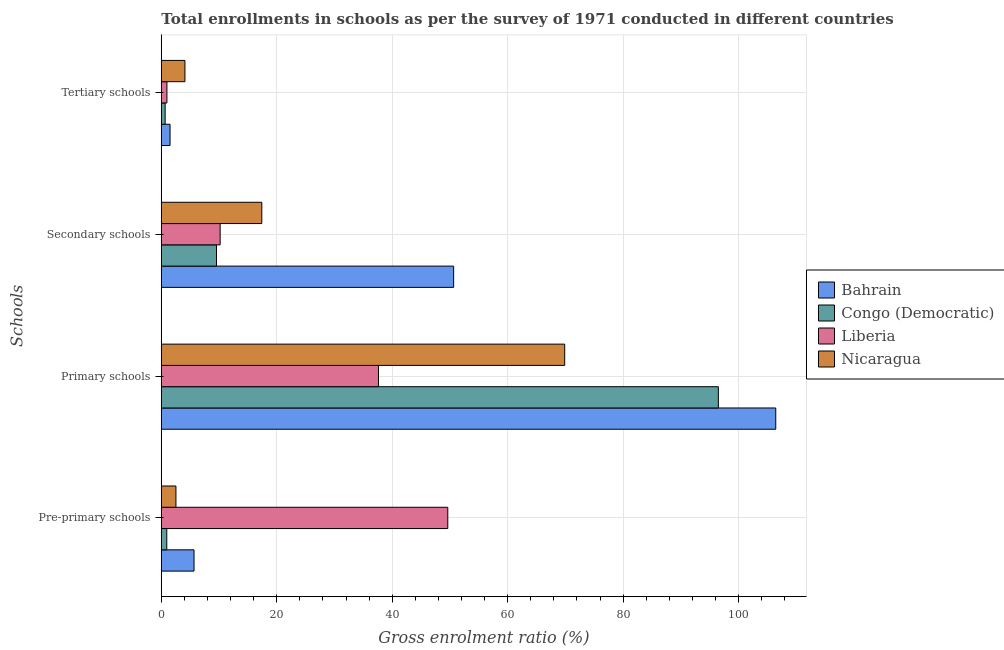Are the number of bars per tick equal to the number of legend labels?
Keep it short and to the point. Yes. What is the label of the 1st group of bars from the top?
Your answer should be compact. Tertiary schools. What is the gross enrolment ratio in pre-primary schools in Congo (Democratic)?
Provide a short and direct response. 0.95. Across all countries, what is the maximum gross enrolment ratio in secondary schools?
Offer a terse response. 50.63. Across all countries, what is the minimum gross enrolment ratio in pre-primary schools?
Offer a very short reply. 0.95. In which country was the gross enrolment ratio in pre-primary schools maximum?
Your response must be concise. Liberia. In which country was the gross enrolment ratio in tertiary schools minimum?
Offer a very short reply. Congo (Democratic). What is the total gross enrolment ratio in primary schools in the graph?
Provide a short and direct response. 310.41. What is the difference between the gross enrolment ratio in tertiary schools in Congo (Democratic) and that in Bahrain?
Offer a terse response. -0.85. What is the difference between the gross enrolment ratio in secondary schools in Liberia and the gross enrolment ratio in tertiary schools in Bahrain?
Provide a short and direct response. 8.68. What is the average gross enrolment ratio in tertiary schools per country?
Offer a terse response. 1.81. What is the difference between the gross enrolment ratio in secondary schools and gross enrolment ratio in primary schools in Liberia?
Give a very brief answer. -27.42. What is the ratio of the gross enrolment ratio in secondary schools in Nicaragua to that in Liberia?
Provide a succinct answer. 1.71. Is the gross enrolment ratio in primary schools in Bahrain less than that in Nicaragua?
Provide a succinct answer. No. Is the difference between the gross enrolment ratio in tertiary schools in Congo (Democratic) and Liberia greater than the difference between the gross enrolment ratio in primary schools in Congo (Democratic) and Liberia?
Offer a terse response. No. What is the difference between the highest and the second highest gross enrolment ratio in secondary schools?
Offer a terse response. 33.23. What is the difference between the highest and the lowest gross enrolment ratio in tertiary schools?
Give a very brief answer. 3.43. Is it the case that in every country, the sum of the gross enrolment ratio in tertiary schools and gross enrolment ratio in pre-primary schools is greater than the sum of gross enrolment ratio in primary schools and gross enrolment ratio in secondary schools?
Your answer should be compact. No. What does the 1st bar from the top in Tertiary schools represents?
Provide a succinct answer. Nicaragua. What does the 2nd bar from the bottom in Tertiary schools represents?
Offer a terse response. Congo (Democratic). How many bars are there?
Make the answer very short. 16. How many countries are there in the graph?
Your response must be concise. 4. What is the difference between two consecutive major ticks on the X-axis?
Make the answer very short. 20. Does the graph contain any zero values?
Give a very brief answer. No. Does the graph contain grids?
Make the answer very short. Yes. What is the title of the graph?
Your answer should be very brief. Total enrollments in schools as per the survey of 1971 conducted in different countries. Does "Norway" appear as one of the legend labels in the graph?
Offer a terse response. No. What is the label or title of the X-axis?
Provide a short and direct response. Gross enrolment ratio (%). What is the label or title of the Y-axis?
Keep it short and to the point. Schools. What is the Gross enrolment ratio (%) in Bahrain in Pre-primary schools?
Give a very brief answer. 5.67. What is the Gross enrolment ratio (%) of Congo (Democratic) in Pre-primary schools?
Offer a very short reply. 0.95. What is the Gross enrolment ratio (%) of Liberia in Pre-primary schools?
Your response must be concise. 49.62. What is the Gross enrolment ratio (%) of Nicaragua in Pre-primary schools?
Keep it short and to the point. 2.53. What is the Gross enrolment ratio (%) of Bahrain in Primary schools?
Keep it short and to the point. 106.43. What is the Gross enrolment ratio (%) of Congo (Democratic) in Primary schools?
Ensure brevity in your answer.  96.49. What is the Gross enrolment ratio (%) of Liberia in Primary schools?
Your response must be concise. 37.62. What is the Gross enrolment ratio (%) of Nicaragua in Primary schools?
Your answer should be compact. 69.87. What is the Gross enrolment ratio (%) of Bahrain in Secondary schools?
Offer a very short reply. 50.63. What is the Gross enrolment ratio (%) of Congo (Democratic) in Secondary schools?
Your answer should be very brief. 9.56. What is the Gross enrolment ratio (%) in Liberia in Secondary schools?
Offer a terse response. 10.19. What is the Gross enrolment ratio (%) of Nicaragua in Secondary schools?
Your answer should be compact. 17.41. What is the Gross enrolment ratio (%) in Bahrain in Tertiary schools?
Keep it short and to the point. 1.51. What is the Gross enrolment ratio (%) of Congo (Democratic) in Tertiary schools?
Offer a very short reply. 0.66. What is the Gross enrolment ratio (%) of Liberia in Tertiary schools?
Keep it short and to the point. 0.97. What is the Gross enrolment ratio (%) in Nicaragua in Tertiary schools?
Ensure brevity in your answer.  4.09. Across all Schools, what is the maximum Gross enrolment ratio (%) of Bahrain?
Your answer should be very brief. 106.43. Across all Schools, what is the maximum Gross enrolment ratio (%) in Congo (Democratic)?
Your answer should be very brief. 96.49. Across all Schools, what is the maximum Gross enrolment ratio (%) in Liberia?
Provide a short and direct response. 49.62. Across all Schools, what is the maximum Gross enrolment ratio (%) of Nicaragua?
Ensure brevity in your answer.  69.87. Across all Schools, what is the minimum Gross enrolment ratio (%) in Bahrain?
Offer a very short reply. 1.51. Across all Schools, what is the minimum Gross enrolment ratio (%) of Congo (Democratic)?
Provide a short and direct response. 0.66. Across all Schools, what is the minimum Gross enrolment ratio (%) of Liberia?
Offer a very short reply. 0.97. Across all Schools, what is the minimum Gross enrolment ratio (%) of Nicaragua?
Keep it short and to the point. 2.53. What is the total Gross enrolment ratio (%) in Bahrain in the graph?
Offer a very short reply. 164.24. What is the total Gross enrolment ratio (%) of Congo (Democratic) in the graph?
Make the answer very short. 107.66. What is the total Gross enrolment ratio (%) of Liberia in the graph?
Offer a terse response. 98.4. What is the total Gross enrolment ratio (%) in Nicaragua in the graph?
Offer a terse response. 93.9. What is the difference between the Gross enrolment ratio (%) in Bahrain in Pre-primary schools and that in Primary schools?
Ensure brevity in your answer.  -100.77. What is the difference between the Gross enrolment ratio (%) of Congo (Democratic) in Pre-primary schools and that in Primary schools?
Your answer should be very brief. -95.55. What is the difference between the Gross enrolment ratio (%) of Liberia in Pre-primary schools and that in Primary schools?
Ensure brevity in your answer.  12. What is the difference between the Gross enrolment ratio (%) in Nicaragua in Pre-primary schools and that in Primary schools?
Provide a succinct answer. -67.34. What is the difference between the Gross enrolment ratio (%) in Bahrain in Pre-primary schools and that in Secondary schools?
Make the answer very short. -44.97. What is the difference between the Gross enrolment ratio (%) in Congo (Democratic) in Pre-primary schools and that in Secondary schools?
Offer a very short reply. -8.61. What is the difference between the Gross enrolment ratio (%) of Liberia in Pre-primary schools and that in Secondary schools?
Offer a very short reply. 39.43. What is the difference between the Gross enrolment ratio (%) in Nicaragua in Pre-primary schools and that in Secondary schools?
Give a very brief answer. -14.88. What is the difference between the Gross enrolment ratio (%) of Bahrain in Pre-primary schools and that in Tertiary schools?
Provide a succinct answer. 4.15. What is the difference between the Gross enrolment ratio (%) of Congo (Democratic) in Pre-primary schools and that in Tertiary schools?
Provide a succinct answer. 0.28. What is the difference between the Gross enrolment ratio (%) of Liberia in Pre-primary schools and that in Tertiary schools?
Your answer should be very brief. 48.65. What is the difference between the Gross enrolment ratio (%) of Nicaragua in Pre-primary schools and that in Tertiary schools?
Make the answer very short. -1.56. What is the difference between the Gross enrolment ratio (%) of Bahrain in Primary schools and that in Secondary schools?
Provide a short and direct response. 55.8. What is the difference between the Gross enrolment ratio (%) of Congo (Democratic) in Primary schools and that in Secondary schools?
Provide a succinct answer. 86.94. What is the difference between the Gross enrolment ratio (%) of Liberia in Primary schools and that in Secondary schools?
Give a very brief answer. 27.42. What is the difference between the Gross enrolment ratio (%) in Nicaragua in Primary schools and that in Secondary schools?
Your answer should be very brief. 52.46. What is the difference between the Gross enrolment ratio (%) in Bahrain in Primary schools and that in Tertiary schools?
Provide a short and direct response. 104.92. What is the difference between the Gross enrolment ratio (%) in Congo (Democratic) in Primary schools and that in Tertiary schools?
Make the answer very short. 95.83. What is the difference between the Gross enrolment ratio (%) of Liberia in Primary schools and that in Tertiary schools?
Your answer should be compact. 36.65. What is the difference between the Gross enrolment ratio (%) in Nicaragua in Primary schools and that in Tertiary schools?
Your response must be concise. 65.78. What is the difference between the Gross enrolment ratio (%) of Bahrain in Secondary schools and that in Tertiary schools?
Your answer should be very brief. 49.12. What is the difference between the Gross enrolment ratio (%) of Congo (Democratic) in Secondary schools and that in Tertiary schools?
Your answer should be very brief. 8.89. What is the difference between the Gross enrolment ratio (%) in Liberia in Secondary schools and that in Tertiary schools?
Your answer should be very brief. 9.22. What is the difference between the Gross enrolment ratio (%) of Nicaragua in Secondary schools and that in Tertiary schools?
Provide a succinct answer. 13.32. What is the difference between the Gross enrolment ratio (%) in Bahrain in Pre-primary schools and the Gross enrolment ratio (%) in Congo (Democratic) in Primary schools?
Your answer should be very brief. -90.82. What is the difference between the Gross enrolment ratio (%) of Bahrain in Pre-primary schools and the Gross enrolment ratio (%) of Liberia in Primary schools?
Keep it short and to the point. -31.95. What is the difference between the Gross enrolment ratio (%) in Bahrain in Pre-primary schools and the Gross enrolment ratio (%) in Nicaragua in Primary schools?
Offer a terse response. -64.21. What is the difference between the Gross enrolment ratio (%) of Congo (Democratic) in Pre-primary schools and the Gross enrolment ratio (%) of Liberia in Primary schools?
Your answer should be compact. -36.67. What is the difference between the Gross enrolment ratio (%) in Congo (Democratic) in Pre-primary schools and the Gross enrolment ratio (%) in Nicaragua in Primary schools?
Make the answer very short. -68.93. What is the difference between the Gross enrolment ratio (%) in Liberia in Pre-primary schools and the Gross enrolment ratio (%) in Nicaragua in Primary schools?
Make the answer very short. -20.25. What is the difference between the Gross enrolment ratio (%) of Bahrain in Pre-primary schools and the Gross enrolment ratio (%) of Congo (Democratic) in Secondary schools?
Provide a succinct answer. -3.89. What is the difference between the Gross enrolment ratio (%) in Bahrain in Pre-primary schools and the Gross enrolment ratio (%) in Liberia in Secondary schools?
Keep it short and to the point. -4.53. What is the difference between the Gross enrolment ratio (%) of Bahrain in Pre-primary schools and the Gross enrolment ratio (%) of Nicaragua in Secondary schools?
Ensure brevity in your answer.  -11.74. What is the difference between the Gross enrolment ratio (%) in Congo (Democratic) in Pre-primary schools and the Gross enrolment ratio (%) in Liberia in Secondary schools?
Offer a terse response. -9.25. What is the difference between the Gross enrolment ratio (%) of Congo (Democratic) in Pre-primary schools and the Gross enrolment ratio (%) of Nicaragua in Secondary schools?
Keep it short and to the point. -16.46. What is the difference between the Gross enrolment ratio (%) in Liberia in Pre-primary schools and the Gross enrolment ratio (%) in Nicaragua in Secondary schools?
Provide a short and direct response. 32.21. What is the difference between the Gross enrolment ratio (%) of Bahrain in Pre-primary schools and the Gross enrolment ratio (%) of Congo (Democratic) in Tertiary schools?
Provide a succinct answer. 5. What is the difference between the Gross enrolment ratio (%) in Bahrain in Pre-primary schools and the Gross enrolment ratio (%) in Liberia in Tertiary schools?
Make the answer very short. 4.7. What is the difference between the Gross enrolment ratio (%) in Bahrain in Pre-primary schools and the Gross enrolment ratio (%) in Nicaragua in Tertiary schools?
Your answer should be compact. 1.57. What is the difference between the Gross enrolment ratio (%) of Congo (Democratic) in Pre-primary schools and the Gross enrolment ratio (%) of Liberia in Tertiary schools?
Give a very brief answer. -0.02. What is the difference between the Gross enrolment ratio (%) of Congo (Democratic) in Pre-primary schools and the Gross enrolment ratio (%) of Nicaragua in Tertiary schools?
Ensure brevity in your answer.  -3.15. What is the difference between the Gross enrolment ratio (%) in Liberia in Pre-primary schools and the Gross enrolment ratio (%) in Nicaragua in Tertiary schools?
Offer a very short reply. 45.53. What is the difference between the Gross enrolment ratio (%) in Bahrain in Primary schools and the Gross enrolment ratio (%) in Congo (Democratic) in Secondary schools?
Offer a terse response. 96.88. What is the difference between the Gross enrolment ratio (%) in Bahrain in Primary schools and the Gross enrolment ratio (%) in Liberia in Secondary schools?
Your answer should be very brief. 96.24. What is the difference between the Gross enrolment ratio (%) of Bahrain in Primary schools and the Gross enrolment ratio (%) of Nicaragua in Secondary schools?
Your answer should be very brief. 89.02. What is the difference between the Gross enrolment ratio (%) of Congo (Democratic) in Primary schools and the Gross enrolment ratio (%) of Liberia in Secondary schools?
Your response must be concise. 86.3. What is the difference between the Gross enrolment ratio (%) of Congo (Democratic) in Primary schools and the Gross enrolment ratio (%) of Nicaragua in Secondary schools?
Your answer should be very brief. 79.08. What is the difference between the Gross enrolment ratio (%) of Liberia in Primary schools and the Gross enrolment ratio (%) of Nicaragua in Secondary schools?
Ensure brevity in your answer.  20.21. What is the difference between the Gross enrolment ratio (%) in Bahrain in Primary schools and the Gross enrolment ratio (%) in Congo (Democratic) in Tertiary schools?
Offer a very short reply. 105.77. What is the difference between the Gross enrolment ratio (%) in Bahrain in Primary schools and the Gross enrolment ratio (%) in Liberia in Tertiary schools?
Give a very brief answer. 105.46. What is the difference between the Gross enrolment ratio (%) of Bahrain in Primary schools and the Gross enrolment ratio (%) of Nicaragua in Tertiary schools?
Provide a succinct answer. 102.34. What is the difference between the Gross enrolment ratio (%) of Congo (Democratic) in Primary schools and the Gross enrolment ratio (%) of Liberia in Tertiary schools?
Ensure brevity in your answer.  95.52. What is the difference between the Gross enrolment ratio (%) in Congo (Democratic) in Primary schools and the Gross enrolment ratio (%) in Nicaragua in Tertiary schools?
Provide a succinct answer. 92.4. What is the difference between the Gross enrolment ratio (%) in Liberia in Primary schools and the Gross enrolment ratio (%) in Nicaragua in Tertiary schools?
Ensure brevity in your answer.  33.53. What is the difference between the Gross enrolment ratio (%) in Bahrain in Secondary schools and the Gross enrolment ratio (%) in Congo (Democratic) in Tertiary schools?
Keep it short and to the point. 49.97. What is the difference between the Gross enrolment ratio (%) in Bahrain in Secondary schools and the Gross enrolment ratio (%) in Liberia in Tertiary schools?
Your answer should be compact. 49.66. What is the difference between the Gross enrolment ratio (%) in Bahrain in Secondary schools and the Gross enrolment ratio (%) in Nicaragua in Tertiary schools?
Your answer should be very brief. 46.54. What is the difference between the Gross enrolment ratio (%) of Congo (Democratic) in Secondary schools and the Gross enrolment ratio (%) of Liberia in Tertiary schools?
Provide a succinct answer. 8.59. What is the difference between the Gross enrolment ratio (%) of Congo (Democratic) in Secondary schools and the Gross enrolment ratio (%) of Nicaragua in Tertiary schools?
Your answer should be very brief. 5.46. What is the difference between the Gross enrolment ratio (%) in Liberia in Secondary schools and the Gross enrolment ratio (%) in Nicaragua in Tertiary schools?
Make the answer very short. 6.1. What is the average Gross enrolment ratio (%) of Bahrain per Schools?
Keep it short and to the point. 41.06. What is the average Gross enrolment ratio (%) in Congo (Democratic) per Schools?
Offer a terse response. 26.91. What is the average Gross enrolment ratio (%) of Liberia per Schools?
Your answer should be very brief. 24.6. What is the average Gross enrolment ratio (%) of Nicaragua per Schools?
Keep it short and to the point. 23.48. What is the difference between the Gross enrolment ratio (%) of Bahrain and Gross enrolment ratio (%) of Congo (Democratic) in Pre-primary schools?
Keep it short and to the point. 4.72. What is the difference between the Gross enrolment ratio (%) of Bahrain and Gross enrolment ratio (%) of Liberia in Pre-primary schools?
Provide a short and direct response. -43.95. What is the difference between the Gross enrolment ratio (%) of Bahrain and Gross enrolment ratio (%) of Nicaragua in Pre-primary schools?
Offer a very short reply. 3.13. What is the difference between the Gross enrolment ratio (%) in Congo (Democratic) and Gross enrolment ratio (%) in Liberia in Pre-primary schools?
Give a very brief answer. -48.67. What is the difference between the Gross enrolment ratio (%) in Congo (Democratic) and Gross enrolment ratio (%) in Nicaragua in Pre-primary schools?
Provide a succinct answer. -1.59. What is the difference between the Gross enrolment ratio (%) in Liberia and Gross enrolment ratio (%) in Nicaragua in Pre-primary schools?
Your response must be concise. 47.09. What is the difference between the Gross enrolment ratio (%) in Bahrain and Gross enrolment ratio (%) in Congo (Democratic) in Primary schools?
Give a very brief answer. 9.94. What is the difference between the Gross enrolment ratio (%) in Bahrain and Gross enrolment ratio (%) in Liberia in Primary schools?
Provide a short and direct response. 68.81. What is the difference between the Gross enrolment ratio (%) in Bahrain and Gross enrolment ratio (%) in Nicaragua in Primary schools?
Offer a terse response. 36.56. What is the difference between the Gross enrolment ratio (%) in Congo (Democratic) and Gross enrolment ratio (%) in Liberia in Primary schools?
Offer a terse response. 58.87. What is the difference between the Gross enrolment ratio (%) in Congo (Democratic) and Gross enrolment ratio (%) in Nicaragua in Primary schools?
Provide a succinct answer. 26.62. What is the difference between the Gross enrolment ratio (%) of Liberia and Gross enrolment ratio (%) of Nicaragua in Primary schools?
Ensure brevity in your answer.  -32.25. What is the difference between the Gross enrolment ratio (%) of Bahrain and Gross enrolment ratio (%) of Congo (Democratic) in Secondary schools?
Provide a succinct answer. 41.08. What is the difference between the Gross enrolment ratio (%) in Bahrain and Gross enrolment ratio (%) in Liberia in Secondary schools?
Your answer should be compact. 40.44. What is the difference between the Gross enrolment ratio (%) of Bahrain and Gross enrolment ratio (%) of Nicaragua in Secondary schools?
Make the answer very short. 33.23. What is the difference between the Gross enrolment ratio (%) of Congo (Democratic) and Gross enrolment ratio (%) of Liberia in Secondary schools?
Provide a succinct answer. -0.64. What is the difference between the Gross enrolment ratio (%) in Congo (Democratic) and Gross enrolment ratio (%) in Nicaragua in Secondary schools?
Provide a succinct answer. -7.85. What is the difference between the Gross enrolment ratio (%) in Liberia and Gross enrolment ratio (%) in Nicaragua in Secondary schools?
Provide a succinct answer. -7.21. What is the difference between the Gross enrolment ratio (%) of Bahrain and Gross enrolment ratio (%) of Congo (Democratic) in Tertiary schools?
Offer a very short reply. 0.85. What is the difference between the Gross enrolment ratio (%) of Bahrain and Gross enrolment ratio (%) of Liberia in Tertiary schools?
Make the answer very short. 0.54. What is the difference between the Gross enrolment ratio (%) of Bahrain and Gross enrolment ratio (%) of Nicaragua in Tertiary schools?
Your response must be concise. -2.58. What is the difference between the Gross enrolment ratio (%) of Congo (Democratic) and Gross enrolment ratio (%) of Liberia in Tertiary schools?
Your answer should be compact. -0.3. What is the difference between the Gross enrolment ratio (%) of Congo (Democratic) and Gross enrolment ratio (%) of Nicaragua in Tertiary schools?
Give a very brief answer. -3.43. What is the difference between the Gross enrolment ratio (%) in Liberia and Gross enrolment ratio (%) in Nicaragua in Tertiary schools?
Your response must be concise. -3.12. What is the ratio of the Gross enrolment ratio (%) in Bahrain in Pre-primary schools to that in Primary schools?
Your answer should be very brief. 0.05. What is the ratio of the Gross enrolment ratio (%) of Congo (Democratic) in Pre-primary schools to that in Primary schools?
Your answer should be compact. 0.01. What is the ratio of the Gross enrolment ratio (%) in Liberia in Pre-primary schools to that in Primary schools?
Your answer should be very brief. 1.32. What is the ratio of the Gross enrolment ratio (%) of Nicaragua in Pre-primary schools to that in Primary schools?
Provide a succinct answer. 0.04. What is the ratio of the Gross enrolment ratio (%) of Bahrain in Pre-primary schools to that in Secondary schools?
Provide a short and direct response. 0.11. What is the ratio of the Gross enrolment ratio (%) in Congo (Democratic) in Pre-primary schools to that in Secondary schools?
Ensure brevity in your answer.  0.1. What is the ratio of the Gross enrolment ratio (%) of Liberia in Pre-primary schools to that in Secondary schools?
Offer a very short reply. 4.87. What is the ratio of the Gross enrolment ratio (%) in Nicaragua in Pre-primary schools to that in Secondary schools?
Your answer should be very brief. 0.15. What is the ratio of the Gross enrolment ratio (%) in Bahrain in Pre-primary schools to that in Tertiary schools?
Ensure brevity in your answer.  3.74. What is the ratio of the Gross enrolment ratio (%) of Congo (Democratic) in Pre-primary schools to that in Tertiary schools?
Your answer should be very brief. 1.42. What is the ratio of the Gross enrolment ratio (%) of Liberia in Pre-primary schools to that in Tertiary schools?
Your answer should be compact. 51.16. What is the ratio of the Gross enrolment ratio (%) of Nicaragua in Pre-primary schools to that in Tertiary schools?
Provide a short and direct response. 0.62. What is the ratio of the Gross enrolment ratio (%) in Bahrain in Primary schools to that in Secondary schools?
Your answer should be very brief. 2.1. What is the ratio of the Gross enrolment ratio (%) of Congo (Democratic) in Primary schools to that in Secondary schools?
Your answer should be very brief. 10.1. What is the ratio of the Gross enrolment ratio (%) in Liberia in Primary schools to that in Secondary schools?
Give a very brief answer. 3.69. What is the ratio of the Gross enrolment ratio (%) in Nicaragua in Primary schools to that in Secondary schools?
Provide a succinct answer. 4.01. What is the ratio of the Gross enrolment ratio (%) of Bahrain in Primary schools to that in Tertiary schools?
Make the answer very short. 70.32. What is the ratio of the Gross enrolment ratio (%) of Congo (Democratic) in Primary schools to that in Tertiary schools?
Keep it short and to the point. 145.12. What is the ratio of the Gross enrolment ratio (%) of Liberia in Primary schools to that in Tertiary schools?
Make the answer very short. 38.78. What is the ratio of the Gross enrolment ratio (%) in Nicaragua in Primary schools to that in Tertiary schools?
Ensure brevity in your answer.  17.08. What is the ratio of the Gross enrolment ratio (%) of Bahrain in Secondary schools to that in Tertiary schools?
Provide a succinct answer. 33.46. What is the ratio of the Gross enrolment ratio (%) in Congo (Democratic) in Secondary schools to that in Tertiary schools?
Make the answer very short. 14.37. What is the ratio of the Gross enrolment ratio (%) of Liberia in Secondary schools to that in Tertiary schools?
Make the answer very short. 10.51. What is the ratio of the Gross enrolment ratio (%) in Nicaragua in Secondary schools to that in Tertiary schools?
Ensure brevity in your answer.  4.25. What is the difference between the highest and the second highest Gross enrolment ratio (%) of Bahrain?
Your answer should be very brief. 55.8. What is the difference between the highest and the second highest Gross enrolment ratio (%) of Congo (Democratic)?
Your answer should be compact. 86.94. What is the difference between the highest and the second highest Gross enrolment ratio (%) of Liberia?
Ensure brevity in your answer.  12. What is the difference between the highest and the second highest Gross enrolment ratio (%) in Nicaragua?
Ensure brevity in your answer.  52.46. What is the difference between the highest and the lowest Gross enrolment ratio (%) in Bahrain?
Your answer should be very brief. 104.92. What is the difference between the highest and the lowest Gross enrolment ratio (%) in Congo (Democratic)?
Ensure brevity in your answer.  95.83. What is the difference between the highest and the lowest Gross enrolment ratio (%) in Liberia?
Provide a short and direct response. 48.65. What is the difference between the highest and the lowest Gross enrolment ratio (%) in Nicaragua?
Your answer should be very brief. 67.34. 